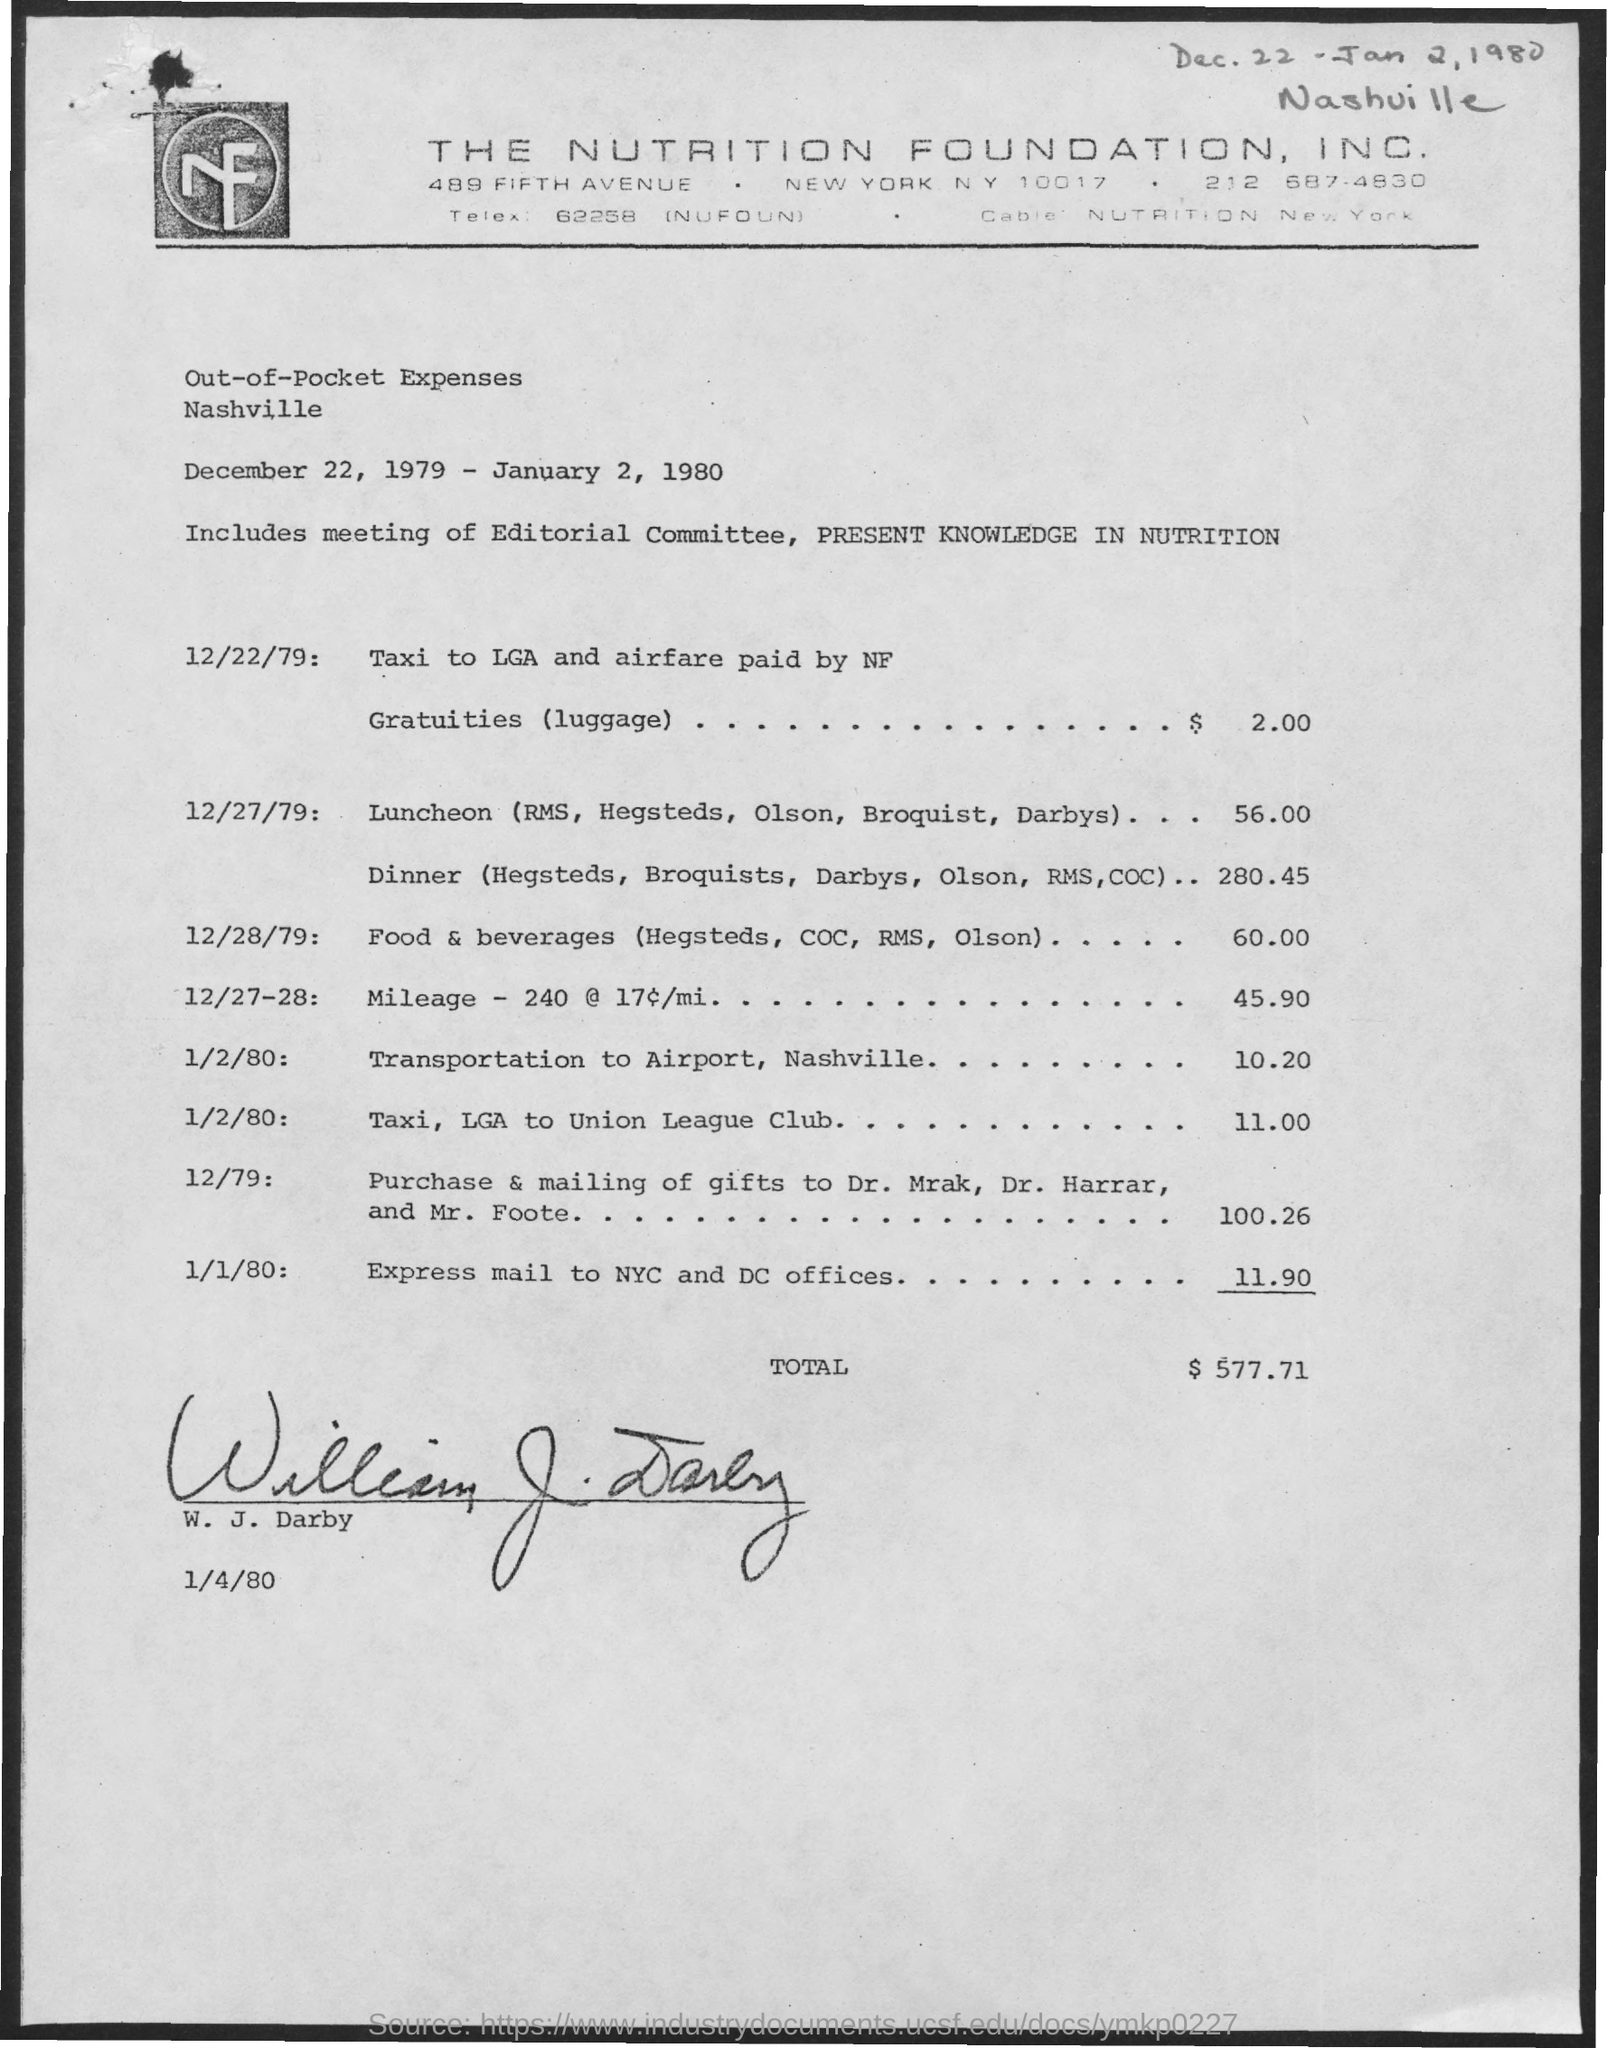What are the dates scheduled for the meeting ?
Give a very brief answer. December 22, 1979- January 2, 1980. What is the total out of pocket  expenses mentioned in the given page ?
Provide a short and direct response. $ 577.71. 